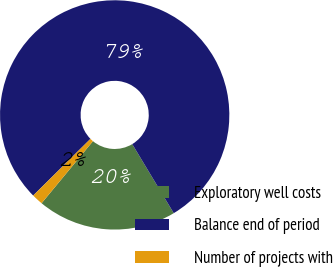Convert chart. <chart><loc_0><loc_0><loc_500><loc_500><pie_chart><fcel>Exploratory well costs<fcel>Balance end of period<fcel>Number of projects with<nl><fcel>19.62%<fcel>78.8%<fcel>1.58%<nl></chart> 